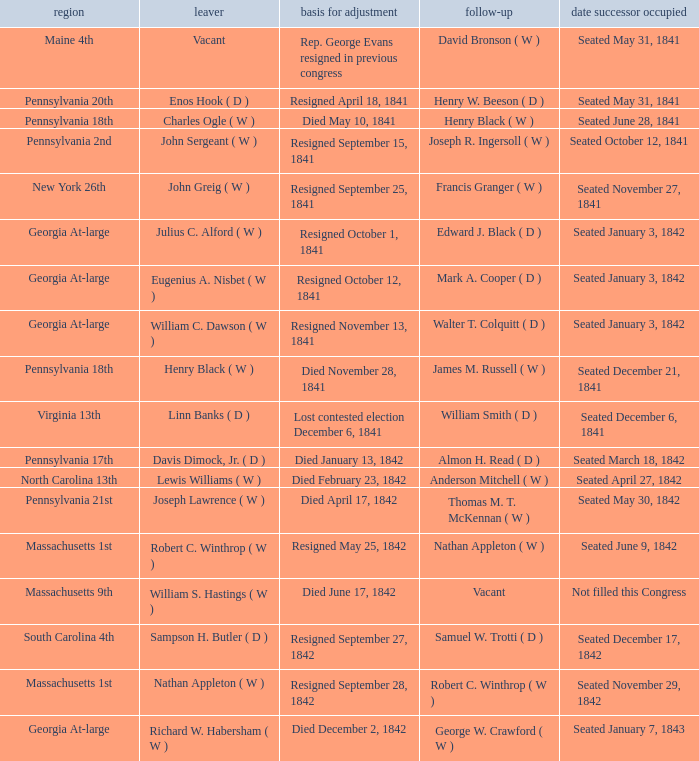Name the successor for north carolina 13th Anderson Mitchell ( W ). 